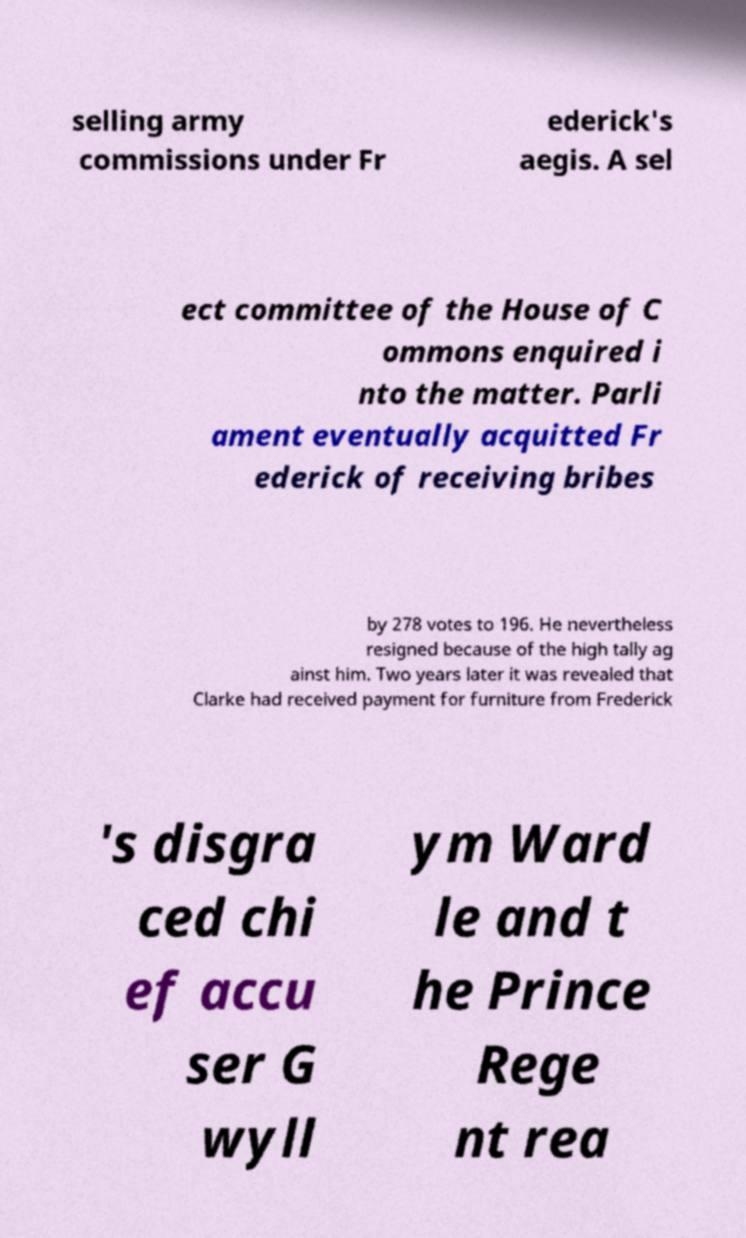Please read and relay the text visible in this image. What does it say? selling army commissions under Fr ederick's aegis. A sel ect committee of the House of C ommons enquired i nto the matter. Parli ament eventually acquitted Fr ederick of receiving bribes by 278 votes to 196. He nevertheless resigned because of the high tally ag ainst him. Two years later it was revealed that Clarke had received payment for furniture from Frederick 's disgra ced chi ef accu ser G wyll ym Ward le and t he Prince Rege nt rea 